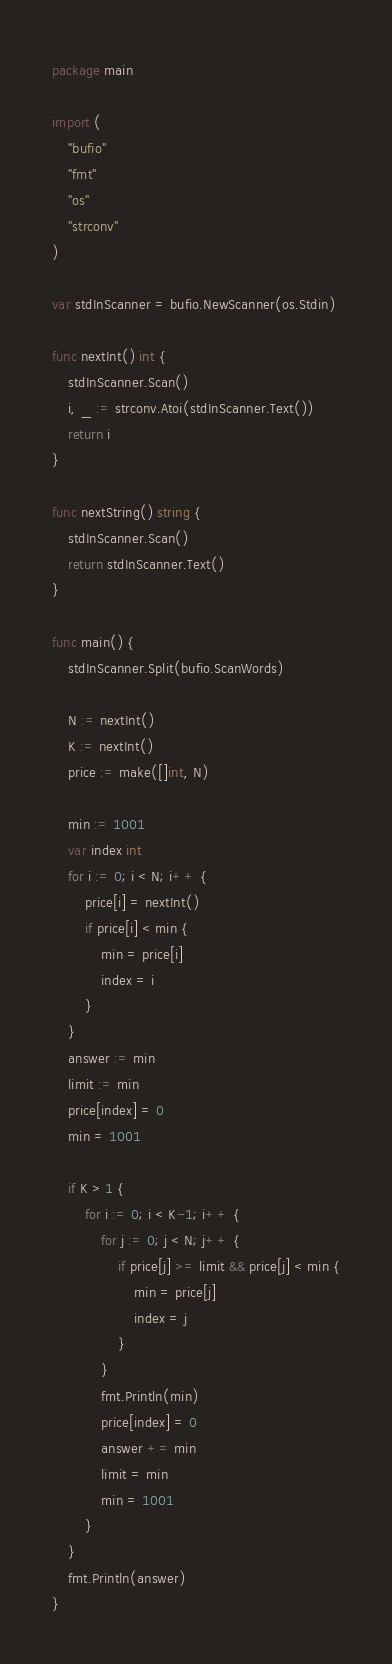Convert code to text. <code><loc_0><loc_0><loc_500><loc_500><_Go_>package main

import (
	"bufio"
	"fmt"
	"os"
	"strconv"
)

var stdInScanner = bufio.NewScanner(os.Stdin)

func nextInt() int {
	stdInScanner.Scan()
	i, _ := strconv.Atoi(stdInScanner.Text())
	return i
}

func nextString() string {
	stdInScanner.Scan()
	return stdInScanner.Text()
}

func main() {
	stdInScanner.Split(bufio.ScanWords)

	N := nextInt()
	K := nextInt()
	price := make([]int, N)

	min := 1001
	var index int
	for i := 0; i < N; i++ {
		price[i] = nextInt()
		if price[i] < min {
			min = price[i]
			index = i
		}
	}
	answer := min
	limit := min
	price[index] = 0
	min = 1001

	if K > 1 {
		for i := 0; i < K-1; i++ {
			for j := 0; j < N; j++ {
				if price[j] >= limit && price[j] < min {
					min = price[j]
					index = j
				}
			}
			fmt.Println(min)
			price[index] = 0
			answer += min
			limit = min
			min = 1001
		}
	}
	fmt.Println(answer)
}
</code> 